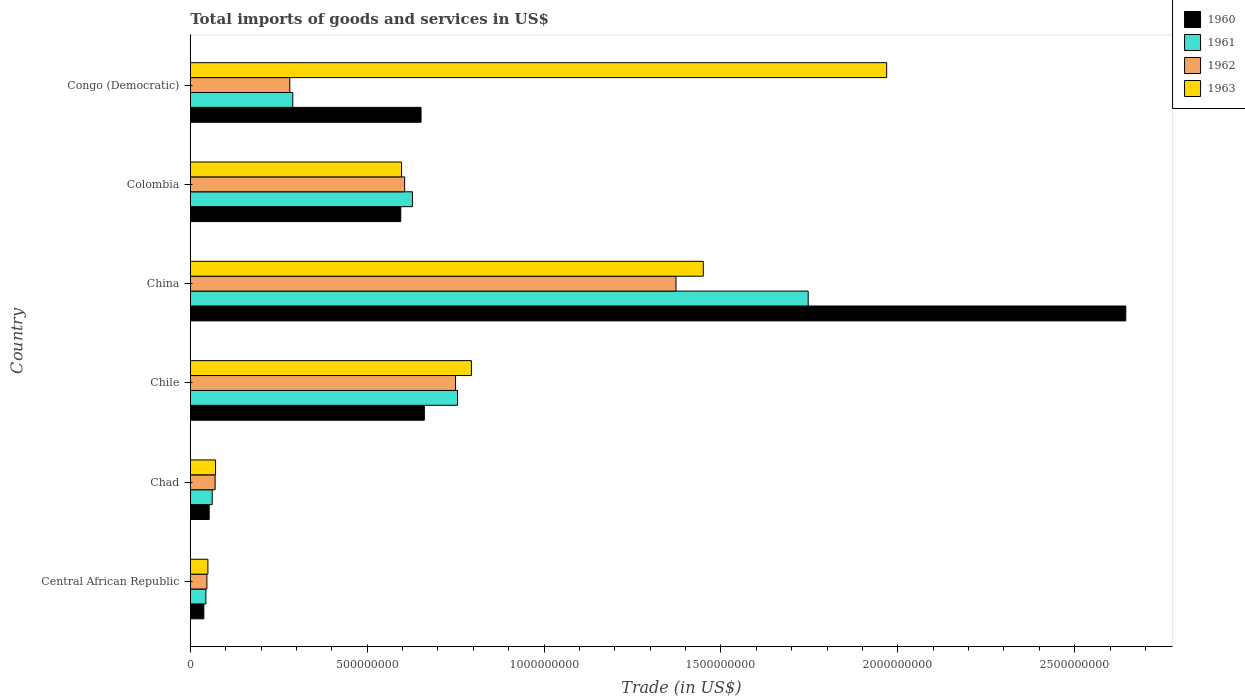Are the number of bars per tick equal to the number of legend labels?
Your answer should be very brief. Yes. In how many cases, is the number of bars for a given country not equal to the number of legend labels?
Your answer should be very brief. 0. What is the total imports of goods and services in 1960 in Central African Republic?
Offer a terse response. 3.83e+07. Across all countries, what is the maximum total imports of goods and services in 1961?
Your response must be concise. 1.75e+09. Across all countries, what is the minimum total imports of goods and services in 1961?
Give a very brief answer. 4.40e+07. In which country was the total imports of goods and services in 1963 maximum?
Keep it short and to the point. Congo (Democratic). In which country was the total imports of goods and services in 1961 minimum?
Your answer should be compact. Central African Republic. What is the total total imports of goods and services in 1960 in the graph?
Provide a succinct answer. 4.64e+09. What is the difference between the total imports of goods and services in 1963 in Chile and that in China?
Ensure brevity in your answer.  -6.55e+08. What is the difference between the total imports of goods and services in 1963 in Colombia and the total imports of goods and services in 1960 in China?
Make the answer very short. -2.05e+09. What is the average total imports of goods and services in 1960 per country?
Offer a very short reply. 7.74e+08. What is the difference between the total imports of goods and services in 1962 and total imports of goods and services in 1960 in Central African Republic?
Give a very brief answer. 8.60e+06. In how many countries, is the total imports of goods and services in 1960 greater than 1200000000 US$?
Your answer should be compact. 1. What is the ratio of the total imports of goods and services in 1960 in Central African Republic to that in Chile?
Your response must be concise. 0.06. Is the total imports of goods and services in 1960 in Central African Republic less than that in Colombia?
Your response must be concise. Yes. Is the difference between the total imports of goods and services in 1962 in Central African Republic and China greater than the difference between the total imports of goods and services in 1960 in Central African Republic and China?
Keep it short and to the point. Yes. What is the difference between the highest and the second highest total imports of goods and services in 1962?
Ensure brevity in your answer.  6.23e+08. What is the difference between the highest and the lowest total imports of goods and services in 1960?
Your answer should be very brief. 2.61e+09. In how many countries, is the total imports of goods and services in 1960 greater than the average total imports of goods and services in 1960 taken over all countries?
Your answer should be compact. 1. Is the sum of the total imports of goods and services in 1963 in Chad and Colombia greater than the maximum total imports of goods and services in 1961 across all countries?
Provide a succinct answer. No. What does the 4th bar from the top in Chad represents?
Offer a terse response. 1960. How many countries are there in the graph?
Offer a terse response. 6. What is the difference between two consecutive major ticks on the X-axis?
Make the answer very short. 5.00e+08. Does the graph contain grids?
Your response must be concise. No. Where does the legend appear in the graph?
Provide a short and direct response. Top right. How many legend labels are there?
Provide a short and direct response. 4. How are the legend labels stacked?
Provide a succinct answer. Vertical. What is the title of the graph?
Your answer should be compact. Total imports of goods and services in US$. Does "1989" appear as one of the legend labels in the graph?
Provide a short and direct response. No. What is the label or title of the X-axis?
Your answer should be compact. Trade (in US$). What is the Trade (in US$) in 1960 in Central African Republic?
Your answer should be compact. 3.83e+07. What is the Trade (in US$) of 1961 in Central African Republic?
Ensure brevity in your answer.  4.40e+07. What is the Trade (in US$) of 1962 in Central African Republic?
Provide a short and direct response. 4.69e+07. What is the Trade (in US$) in 1963 in Central African Republic?
Provide a short and direct response. 4.98e+07. What is the Trade (in US$) in 1960 in Chad?
Ensure brevity in your answer.  5.34e+07. What is the Trade (in US$) in 1961 in Chad?
Make the answer very short. 6.20e+07. What is the Trade (in US$) in 1962 in Chad?
Your response must be concise. 7.02e+07. What is the Trade (in US$) in 1963 in Chad?
Provide a succinct answer. 7.14e+07. What is the Trade (in US$) of 1960 in Chile?
Make the answer very short. 6.62e+08. What is the Trade (in US$) in 1961 in Chile?
Provide a short and direct response. 7.55e+08. What is the Trade (in US$) in 1962 in Chile?
Provide a short and direct response. 7.50e+08. What is the Trade (in US$) of 1963 in Chile?
Your answer should be compact. 7.95e+08. What is the Trade (in US$) in 1960 in China?
Your response must be concise. 2.64e+09. What is the Trade (in US$) of 1961 in China?
Your answer should be compact. 1.75e+09. What is the Trade (in US$) of 1962 in China?
Your response must be concise. 1.37e+09. What is the Trade (in US$) in 1963 in China?
Offer a very short reply. 1.45e+09. What is the Trade (in US$) in 1960 in Colombia?
Your answer should be very brief. 5.95e+08. What is the Trade (in US$) in 1961 in Colombia?
Your answer should be very brief. 6.28e+08. What is the Trade (in US$) of 1962 in Colombia?
Your answer should be compact. 6.06e+08. What is the Trade (in US$) in 1963 in Colombia?
Give a very brief answer. 5.97e+08. What is the Trade (in US$) of 1960 in Congo (Democratic)?
Offer a very short reply. 6.52e+08. What is the Trade (in US$) of 1961 in Congo (Democratic)?
Make the answer very short. 2.90e+08. What is the Trade (in US$) in 1962 in Congo (Democratic)?
Provide a succinct answer. 2.81e+08. What is the Trade (in US$) in 1963 in Congo (Democratic)?
Your answer should be very brief. 1.97e+09. Across all countries, what is the maximum Trade (in US$) of 1960?
Offer a very short reply. 2.64e+09. Across all countries, what is the maximum Trade (in US$) in 1961?
Give a very brief answer. 1.75e+09. Across all countries, what is the maximum Trade (in US$) in 1962?
Provide a short and direct response. 1.37e+09. Across all countries, what is the maximum Trade (in US$) in 1963?
Give a very brief answer. 1.97e+09. Across all countries, what is the minimum Trade (in US$) in 1960?
Your answer should be compact. 3.83e+07. Across all countries, what is the minimum Trade (in US$) of 1961?
Keep it short and to the point. 4.40e+07. Across all countries, what is the minimum Trade (in US$) of 1962?
Provide a short and direct response. 4.69e+07. Across all countries, what is the minimum Trade (in US$) in 1963?
Give a very brief answer. 4.98e+07. What is the total Trade (in US$) in 1960 in the graph?
Ensure brevity in your answer.  4.64e+09. What is the total Trade (in US$) in 1961 in the graph?
Keep it short and to the point. 3.53e+09. What is the total Trade (in US$) in 1962 in the graph?
Your answer should be compact. 3.13e+09. What is the total Trade (in US$) of 1963 in the graph?
Offer a very short reply. 4.93e+09. What is the difference between the Trade (in US$) in 1960 in Central African Republic and that in Chad?
Offer a terse response. -1.51e+07. What is the difference between the Trade (in US$) of 1961 in Central African Republic and that in Chad?
Keep it short and to the point. -1.79e+07. What is the difference between the Trade (in US$) of 1962 in Central African Republic and that in Chad?
Give a very brief answer. -2.33e+07. What is the difference between the Trade (in US$) of 1963 in Central African Republic and that in Chad?
Give a very brief answer. -2.16e+07. What is the difference between the Trade (in US$) in 1960 in Central African Republic and that in Chile?
Provide a short and direct response. -6.23e+08. What is the difference between the Trade (in US$) of 1961 in Central African Republic and that in Chile?
Keep it short and to the point. -7.11e+08. What is the difference between the Trade (in US$) of 1962 in Central African Republic and that in Chile?
Your answer should be compact. -7.03e+08. What is the difference between the Trade (in US$) in 1963 in Central African Republic and that in Chile?
Ensure brevity in your answer.  -7.45e+08. What is the difference between the Trade (in US$) of 1960 in Central African Republic and that in China?
Ensure brevity in your answer.  -2.61e+09. What is the difference between the Trade (in US$) of 1961 in Central African Republic and that in China?
Keep it short and to the point. -1.70e+09. What is the difference between the Trade (in US$) of 1962 in Central African Republic and that in China?
Your answer should be very brief. -1.33e+09. What is the difference between the Trade (in US$) of 1963 in Central African Republic and that in China?
Your response must be concise. -1.40e+09. What is the difference between the Trade (in US$) of 1960 in Central African Republic and that in Colombia?
Give a very brief answer. -5.57e+08. What is the difference between the Trade (in US$) in 1961 in Central African Republic and that in Colombia?
Provide a succinct answer. -5.84e+08. What is the difference between the Trade (in US$) of 1962 in Central African Republic and that in Colombia?
Your answer should be compact. -5.59e+08. What is the difference between the Trade (in US$) of 1963 in Central African Republic and that in Colombia?
Provide a succinct answer. -5.47e+08. What is the difference between the Trade (in US$) in 1960 in Central African Republic and that in Congo (Democratic)?
Offer a very short reply. -6.14e+08. What is the difference between the Trade (in US$) of 1961 in Central African Republic and that in Congo (Democratic)?
Provide a short and direct response. -2.46e+08. What is the difference between the Trade (in US$) in 1962 in Central African Republic and that in Congo (Democratic)?
Ensure brevity in your answer.  -2.34e+08. What is the difference between the Trade (in US$) in 1963 in Central African Republic and that in Congo (Democratic)?
Make the answer very short. -1.92e+09. What is the difference between the Trade (in US$) of 1960 in Chad and that in Chile?
Provide a short and direct response. -6.08e+08. What is the difference between the Trade (in US$) in 1961 in Chad and that in Chile?
Provide a short and direct response. -6.93e+08. What is the difference between the Trade (in US$) in 1962 in Chad and that in Chile?
Your answer should be compact. -6.80e+08. What is the difference between the Trade (in US$) in 1963 in Chad and that in Chile?
Offer a very short reply. -7.23e+08. What is the difference between the Trade (in US$) of 1960 in Chad and that in China?
Provide a short and direct response. -2.59e+09. What is the difference between the Trade (in US$) of 1961 in Chad and that in China?
Offer a very short reply. -1.68e+09. What is the difference between the Trade (in US$) of 1962 in Chad and that in China?
Ensure brevity in your answer.  -1.30e+09. What is the difference between the Trade (in US$) in 1963 in Chad and that in China?
Your response must be concise. -1.38e+09. What is the difference between the Trade (in US$) of 1960 in Chad and that in Colombia?
Make the answer very short. -5.41e+08. What is the difference between the Trade (in US$) in 1961 in Chad and that in Colombia?
Provide a succinct answer. -5.66e+08. What is the difference between the Trade (in US$) in 1962 in Chad and that in Colombia?
Provide a succinct answer. -5.36e+08. What is the difference between the Trade (in US$) of 1963 in Chad and that in Colombia?
Ensure brevity in your answer.  -5.26e+08. What is the difference between the Trade (in US$) of 1960 in Chad and that in Congo (Democratic)?
Ensure brevity in your answer.  -5.99e+08. What is the difference between the Trade (in US$) in 1961 in Chad and that in Congo (Democratic)?
Offer a very short reply. -2.28e+08. What is the difference between the Trade (in US$) in 1962 in Chad and that in Congo (Democratic)?
Make the answer very short. -2.11e+08. What is the difference between the Trade (in US$) in 1963 in Chad and that in Congo (Democratic)?
Your response must be concise. -1.90e+09. What is the difference between the Trade (in US$) in 1960 in Chile and that in China?
Your answer should be compact. -1.98e+09. What is the difference between the Trade (in US$) of 1961 in Chile and that in China?
Your answer should be compact. -9.91e+08. What is the difference between the Trade (in US$) of 1962 in Chile and that in China?
Offer a terse response. -6.23e+08. What is the difference between the Trade (in US$) of 1963 in Chile and that in China?
Offer a terse response. -6.55e+08. What is the difference between the Trade (in US$) of 1960 in Chile and that in Colombia?
Keep it short and to the point. 6.68e+07. What is the difference between the Trade (in US$) of 1961 in Chile and that in Colombia?
Make the answer very short. 1.28e+08. What is the difference between the Trade (in US$) of 1962 in Chile and that in Colombia?
Your answer should be compact. 1.44e+08. What is the difference between the Trade (in US$) in 1963 in Chile and that in Colombia?
Offer a very short reply. 1.97e+08. What is the difference between the Trade (in US$) of 1960 in Chile and that in Congo (Democratic)?
Provide a succinct answer. 9.37e+06. What is the difference between the Trade (in US$) of 1961 in Chile and that in Congo (Democratic)?
Make the answer very short. 4.66e+08. What is the difference between the Trade (in US$) in 1962 in Chile and that in Congo (Democratic)?
Make the answer very short. 4.68e+08. What is the difference between the Trade (in US$) of 1963 in Chile and that in Congo (Democratic)?
Keep it short and to the point. -1.17e+09. What is the difference between the Trade (in US$) in 1960 in China and that in Colombia?
Offer a very short reply. 2.05e+09. What is the difference between the Trade (in US$) of 1961 in China and that in Colombia?
Provide a short and direct response. 1.12e+09. What is the difference between the Trade (in US$) in 1962 in China and that in Colombia?
Your answer should be compact. 7.67e+08. What is the difference between the Trade (in US$) in 1963 in China and that in Colombia?
Ensure brevity in your answer.  8.53e+08. What is the difference between the Trade (in US$) in 1960 in China and that in Congo (Democratic)?
Make the answer very short. 1.99e+09. What is the difference between the Trade (in US$) of 1961 in China and that in Congo (Democratic)?
Your response must be concise. 1.46e+09. What is the difference between the Trade (in US$) in 1962 in China and that in Congo (Democratic)?
Your answer should be very brief. 1.09e+09. What is the difference between the Trade (in US$) of 1963 in China and that in Congo (Democratic)?
Provide a succinct answer. -5.18e+08. What is the difference between the Trade (in US$) of 1960 in Colombia and that in Congo (Democratic)?
Ensure brevity in your answer.  -5.74e+07. What is the difference between the Trade (in US$) of 1961 in Colombia and that in Congo (Democratic)?
Your answer should be very brief. 3.38e+08. What is the difference between the Trade (in US$) of 1962 in Colombia and that in Congo (Democratic)?
Your answer should be very brief. 3.25e+08. What is the difference between the Trade (in US$) of 1963 in Colombia and that in Congo (Democratic)?
Keep it short and to the point. -1.37e+09. What is the difference between the Trade (in US$) of 1960 in Central African Republic and the Trade (in US$) of 1961 in Chad?
Provide a short and direct response. -2.36e+07. What is the difference between the Trade (in US$) of 1960 in Central African Republic and the Trade (in US$) of 1962 in Chad?
Your response must be concise. -3.19e+07. What is the difference between the Trade (in US$) of 1960 in Central African Republic and the Trade (in US$) of 1963 in Chad?
Give a very brief answer. -3.31e+07. What is the difference between the Trade (in US$) of 1961 in Central African Republic and the Trade (in US$) of 1962 in Chad?
Offer a terse response. -2.62e+07. What is the difference between the Trade (in US$) in 1961 in Central African Republic and the Trade (in US$) in 1963 in Chad?
Make the answer very short. -2.74e+07. What is the difference between the Trade (in US$) in 1962 in Central African Republic and the Trade (in US$) in 1963 in Chad?
Provide a short and direct response. -2.45e+07. What is the difference between the Trade (in US$) in 1960 in Central African Republic and the Trade (in US$) in 1961 in Chile?
Your answer should be very brief. -7.17e+08. What is the difference between the Trade (in US$) of 1960 in Central African Republic and the Trade (in US$) of 1962 in Chile?
Your response must be concise. -7.11e+08. What is the difference between the Trade (in US$) in 1960 in Central African Republic and the Trade (in US$) in 1963 in Chile?
Your answer should be compact. -7.56e+08. What is the difference between the Trade (in US$) of 1961 in Central African Republic and the Trade (in US$) of 1962 in Chile?
Offer a very short reply. -7.06e+08. What is the difference between the Trade (in US$) in 1961 in Central African Republic and the Trade (in US$) in 1963 in Chile?
Offer a very short reply. -7.51e+08. What is the difference between the Trade (in US$) in 1962 in Central African Republic and the Trade (in US$) in 1963 in Chile?
Offer a very short reply. -7.48e+08. What is the difference between the Trade (in US$) in 1960 in Central African Republic and the Trade (in US$) in 1961 in China?
Your response must be concise. -1.71e+09. What is the difference between the Trade (in US$) in 1960 in Central African Republic and the Trade (in US$) in 1962 in China?
Keep it short and to the point. -1.33e+09. What is the difference between the Trade (in US$) of 1960 in Central African Republic and the Trade (in US$) of 1963 in China?
Keep it short and to the point. -1.41e+09. What is the difference between the Trade (in US$) of 1961 in Central African Republic and the Trade (in US$) of 1962 in China?
Offer a terse response. -1.33e+09. What is the difference between the Trade (in US$) of 1961 in Central African Republic and the Trade (in US$) of 1963 in China?
Give a very brief answer. -1.41e+09. What is the difference between the Trade (in US$) in 1962 in Central African Republic and the Trade (in US$) in 1963 in China?
Ensure brevity in your answer.  -1.40e+09. What is the difference between the Trade (in US$) of 1960 in Central African Republic and the Trade (in US$) of 1961 in Colombia?
Provide a succinct answer. -5.90e+08. What is the difference between the Trade (in US$) in 1960 in Central African Republic and the Trade (in US$) in 1962 in Colombia?
Keep it short and to the point. -5.68e+08. What is the difference between the Trade (in US$) in 1960 in Central African Republic and the Trade (in US$) in 1963 in Colombia?
Give a very brief answer. -5.59e+08. What is the difference between the Trade (in US$) of 1961 in Central African Republic and the Trade (in US$) of 1962 in Colombia?
Your answer should be compact. -5.62e+08. What is the difference between the Trade (in US$) of 1961 in Central African Republic and the Trade (in US$) of 1963 in Colombia?
Your answer should be compact. -5.53e+08. What is the difference between the Trade (in US$) of 1962 in Central African Republic and the Trade (in US$) of 1963 in Colombia?
Give a very brief answer. -5.50e+08. What is the difference between the Trade (in US$) in 1960 in Central African Republic and the Trade (in US$) in 1961 in Congo (Democratic)?
Provide a short and direct response. -2.51e+08. What is the difference between the Trade (in US$) of 1960 in Central African Republic and the Trade (in US$) of 1962 in Congo (Democratic)?
Keep it short and to the point. -2.43e+08. What is the difference between the Trade (in US$) in 1960 in Central African Republic and the Trade (in US$) in 1963 in Congo (Democratic)?
Your answer should be compact. -1.93e+09. What is the difference between the Trade (in US$) in 1961 in Central African Republic and the Trade (in US$) in 1962 in Congo (Democratic)?
Your answer should be compact. -2.37e+08. What is the difference between the Trade (in US$) of 1961 in Central African Republic and the Trade (in US$) of 1963 in Congo (Democratic)?
Give a very brief answer. -1.92e+09. What is the difference between the Trade (in US$) in 1962 in Central African Republic and the Trade (in US$) in 1963 in Congo (Democratic)?
Your answer should be compact. -1.92e+09. What is the difference between the Trade (in US$) of 1960 in Chad and the Trade (in US$) of 1961 in Chile?
Make the answer very short. -7.02e+08. What is the difference between the Trade (in US$) of 1960 in Chad and the Trade (in US$) of 1962 in Chile?
Your answer should be very brief. -6.96e+08. What is the difference between the Trade (in US$) in 1960 in Chad and the Trade (in US$) in 1963 in Chile?
Offer a terse response. -7.41e+08. What is the difference between the Trade (in US$) in 1961 in Chad and the Trade (in US$) in 1962 in Chile?
Provide a succinct answer. -6.88e+08. What is the difference between the Trade (in US$) of 1961 in Chad and the Trade (in US$) of 1963 in Chile?
Your answer should be compact. -7.33e+08. What is the difference between the Trade (in US$) in 1962 in Chad and the Trade (in US$) in 1963 in Chile?
Ensure brevity in your answer.  -7.25e+08. What is the difference between the Trade (in US$) of 1960 in Chad and the Trade (in US$) of 1961 in China?
Your answer should be compact. -1.69e+09. What is the difference between the Trade (in US$) in 1960 in Chad and the Trade (in US$) in 1962 in China?
Provide a short and direct response. -1.32e+09. What is the difference between the Trade (in US$) of 1960 in Chad and the Trade (in US$) of 1963 in China?
Your answer should be very brief. -1.40e+09. What is the difference between the Trade (in US$) in 1961 in Chad and the Trade (in US$) in 1962 in China?
Keep it short and to the point. -1.31e+09. What is the difference between the Trade (in US$) in 1961 in Chad and the Trade (in US$) in 1963 in China?
Your response must be concise. -1.39e+09. What is the difference between the Trade (in US$) of 1962 in Chad and the Trade (in US$) of 1963 in China?
Your answer should be compact. -1.38e+09. What is the difference between the Trade (in US$) of 1960 in Chad and the Trade (in US$) of 1961 in Colombia?
Your response must be concise. -5.75e+08. What is the difference between the Trade (in US$) in 1960 in Chad and the Trade (in US$) in 1962 in Colombia?
Offer a very short reply. -5.53e+08. What is the difference between the Trade (in US$) of 1960 in Chad and the Trade (in US$) of 1963 in Colombia?
Ensure brevity in your answer.  -5.44e+08. What is the difference between the Trade (in US$) in 1961 in Chad and the Trade (in US$) in 1962 in Colombia?
Offer a very short reply. -5.44e+08. What is the difference between the Trade (in US$) of 1961 in Chad and the Trade (in US$) of 1963 in Colombia?
Your answer should be compact. -5.35e+08. What is the difference between the Trade (in US$) of 1962 in Chad and the Trade (in US$) of 1963 in Colombia?
Your answer should be very brief. -5.27e+08. What is the difference between the Trade (in US$) of 1960 in Chad and the Trade (in US$) of 1961 in Congo (Democratic)?
Offer a very short reply. -2.36e+08. What is the difference between the Trade (in US$) in 1960 in Chad and the Trade (in US$) in 1962 in Congo (Democratic)?
Provide a short and direct response. -2.28e+08. What is the difference between the Trade (in US$) in 1960 in Chad and the Trade (in US$) in 1963 in Congo (Democratic)?
Your answer should be very brief. -1.92e+09. What is the difference between the Trade (in US$) in 1961 in Chad and the Trade (in US$) in 1962 in Congo (Democratic)?
Offer a terse response. -2.19e+08. What is the difference between the Trade (in US$) of 1961 in Chad and the Trade (in US$) of 1963 in Congo (Democratic)?
Make the answer very short. -1.91e+09. What is the difference between the Trade (in US$) of 1962 in Chad and the Trade (in US$) of 1963 in Congo (Democratic)?
Your answer should be very brief. -1.90e+09. What is the difference between the Trade (in US$) in 1960 in Chile and the Trade (in US$) in 1961 in China?
Provide a short and direct response. -1.09e+09. What is the difference between the Trade (in US$) in 1960 in Chile and the Trade (in US$) in 1962 in China?
Your answer should be compact. -7.11e+08. What is the difference between the Trade (in US$) of 1960 in Chile and the Trade (in US$) of 1963 in China?
Keep it short and to the point. -7.88e+08. What is the difference between the Trade (in US$) in 1961 in Chile and the Trade (in US$) in 1962 in China?
Provide a succinct answer. -6.18e+08. What is the difference between the Trade (in US$) of 1961 in Chile and the Trade (in US$) of 1963 in China?
Offer a terse response. -6.95e+08. What is the difference between the Trade (in US$) of 1962 in Chile and the Trade (in US$) of 1963 in China?
Give a very brief answer. -7.00e+08. What is the difference between the Trade (in US$) of 1960 in Chile and the Trade (in US$) of 1961 in Colombia?
Your answer should be compact. 3.37e+07. What is the difference between the Trade (in US$) of 1960 in Chile and the Trade (in US$) of 1962 in Colombia?
Your answer should be very brief. 5.57e+07. What is the difference between the Trade (in US$) of 1960 in Chile and the Trade (in US$) of 1963 in Colombia?
Ensure brevity in your answer.  6.44e+07. What is the difference between the Trade (in US$) in 1961 in Chile and the Trade (in US$) in 1962 in Colombia?
Make the answer very short. 1.50e+08. What is the difference between the Trade (in US$) in 1961 in Chile and the Trade (in US$) in 1963 in Colombia?
Your answer should be compact. 1.58e+08. What is the difference between the Trade (in US$) of 1962 in Chile and the Trade (in US$) of 1963 in Colombia?
Give a very brief answer. 1.52e+08. What is the difference between the Trade (in US$) of 1960 in Chile and the Trade (in US$) of 1961 in Congo (Democratic)?
Provide a short and direct response. 3.72e+08. What is the difference between the Trade (in US$) in 1960 in Chile and the Trade (in US$) in 1962 in Congo (Democratic)?
Make the answer very short. 3.80e+08. What is the difference between the Trade (in US$) of 1960 in Chile and the Trade (in US$) of 1963 in Congo (Democratic)?
Give a very brief answer. -1.31e+09. What is the difference between the Trade (in US$) of 1961 in Chile and the Trade (in US$) of 1962 in Congo (Democratic)?
Give a very brief answer. 4.74e+08. What is the difference between the Trade (in US$) in 1961 in Chile and the Trade (in US$) in 1963 in Congo (Democratic)?
Ensure brevity in your answer.  -1.21e+09. What is the difference between the Trade (in US$) in 1962 in Chile and the Trade (in US$) in 1963 in Congo (Democratic)?
Give a very brief answer. -1.22e+09. What is the difference between the Trade (in US$) in 1960 in China and the Trade (in US$) in 1961 in Colombia?
Your answer should be very brief. 2.02e+09. What is the difference between the Trade (in US$) in 1960 in China and the Trade (in US$) in 1962 in Colombia?
Your response must be concise. 2.04e+09. What is the difference between the Trade (in US$) in 1960 in China and the Trade (in US$) in 1963 in Colombia?
Keep it short and to the point. 2.05e+09. What is the difference between the Trade (in US$) in 1961 in China and the Trade (in US$) in 1962 in Colombia?
Offer a very short reply. 1.14e+09. What is the difference between the Trade (in US$) of 1961 in China and the Trade (in US$) of 1963 in Colombia?
Offer a very short reply. 1.15e+09. What is the difference between the Trade (in US$) of 1962 in China and the Trade (in US$) of 1963 in Colombia?
Provide a short and direct response. 7.76e+08. What is the difference between the Trade (in US$) of 1960 in China and the Trade (in US$) of 1961 in Congo (Democratic)?
Provide a succinct answer. 2.35e+09. What is the difference between the Trade (in US$) in 1960 in China and the Trade (in US$) in 1962 in Congo (Democratic)?
Your answer should be very brief. 2.36e+09. What is the difference between the Trade (in US$) of 1960 in China and the Trade (in US$) of 1963 in Congo (Democratic)?
Your answer should be very brief. 6.76e+08. What is the difference between the Trade (in US$) of 1961 in China and the Trade (in US$) of 1962 in Congo (Democratic)?
Offer a very short reply. 1.47e+09. What is the difference between the Trade (in US$) of 1961 in China and the Trade (in US$) of 1963 in Congo (Democratic)?
Your answer should be very brief. -2.22e+08. What is the difference between the Trade (in US$) in 1962 in China and the Trade (in US$) in 1963 in Congo (Democratic)?
Provide a succinct answer. -5.96e+08. What is the difference between the Trade (in US$) in 1960 in Colombia and the Trade (in US$) in 1961 in Congo (Democratic)?
Offer a very short reply. 3.05e+08. What is the difference between the Trade (in US$) in 1960 in Colombia and the Trade (in US$) in 1962 in Congo (Democratic)?
Make the answer very short. 3.14e+08. What is the difference between the Trade (in US$) of 1960 in Colombia and the Trade (in US$) of 1963 in Congo (Democratic)?
Provide a short and direct response. -1.37e+09. What is the difference between the Trade (in US$) of 1961 in Colombia and the Trade (in US$) of 1962 in Congo (Democratic)?
Ensure brevity in your answer.  3.47e+08. What is the difference between the Trade (in US$) of 1961 in Colombia and the Trade (in US$) of 1963 in Congo (Democratic)?
Offer a very short reply. -1.34e+09. What is the difference between the Trade (in US$) in 1962 in Colombia and the Trade (in US$) in 1963 in Congo (Democratic)?
Offer a terse response. -1.36e+09. What is the average Trade (in US$) of 1960 per country?
Provide a short and direct response. 7.74e+08. What is the average Trade (in US$) of 1961 per country?
Offer a very short reply. 5.88e+08. What is the average Trade (in US$) of 1962 per country?
Your answer should be very brief. 5.21e+08. What is the average Trade (in US$) in 1963 per country?
Your response must be concise. 8.22e+08. What is the difference between the Trade (in US$) in 1960 and Trade (in US$) in 1961 in Central African Republic?
Provide a succinct answer. -5.70e+06. What is the difference between the Trade (in US$) in 1960 and Trade (in US$) in 1962 in Central African Republic?
Provide a short and direct response. -8.60e+06. What is the difference between the Trade (in US$) in 1960 and Trade (in US$) in 1963 in Central African Republic?
Offer a very short reply. -1.15e+07. What is the difference between the Trade (in US$) of 1961 and Trade (in US$) of 1962 in Central African Republic?
Provide a succinct answer. -2.90e+06. What is the difference between the Trade (in US$) in 1961 and Trade (in US$) in 1963 in Central African Republic?
Ensure brevity in your answer.  -5.76e+06. What is the difference between the Trade (in US$) in 1962 and Trade (in US$) in 1963 in Central African Republic?
Keep it short and to the point. -2.86e+06. What is the difference between the Trade (in US$) in 1960 and Trade (in US$) in 1961 in Chad?
Provide a short and direct response. -8.55e+06. What is the difference between the Trade (in US$) of 1960 and Trade (in US$) of 1962 in Chad?
Offer a very short reply. -1.68e+07. What is the difference between the Trade (in US$) of 1960 and Trade (in US$) of 1963 in Chad?
Your answer should be very brief. -1.80e+07. What is the difference between the Trade (in US$) of 1961 and Trade (in US$) of 1962 in Chad?
Your answer should be compact. -8.23e+06. What is the difference between the Trade (in US$) of 1961 and Trade (in US$) of 1963 in Chad?
Give a very brief answer. -9.45e+06. What is the difference between the Trade (in US$) in 1962 and Trade (in US$) in 1963 in Chad?
Ensure brevity in your answer.  -1.22e+06. What is the difference between the Trade (in US$) of 1960 and Trade (in US$) of 1961 in Chile?
Offer a very short reply. -9.38e+07. What is the difference between the Trade (in US$) of 1960 and Trade (in US$) of 1962 in Chile?
Offer a terse response. -8.81e+07. What is the difference between the Trade (in US$) of 1960 and Trade (in US$) of 1963 in Chile?
Your response must be concise. -1.33e+08. What is the difference between the Trade (in US$) in 1961 and Trade (in US$) in 1962 in Chile?
Give a very brief answer. 5.71e+06. What is the difference between the Trade (in US$) in 1961 and Trade (in US$) in 1963 in Chile?
Provide a short and direct response. -3.92e+07. What is the difference between the Trade (in US$) of 1962 and Trade (in US$) of 1963 in Chile?
Your answer should be very brief. -4.50e+07. What is the difference between the Trade (in US$) in 1960 and Trade (in US$) in 1961 in China?
Your answer should be compact. 8.98e+08. What is the difference between the Trade (in US$) in 1960 and Trade (in US$) in 1962 in China?
Offer a terse response. 1.27e+09. What is the difference between the Trade (in US$) in 1960 and Trade (in US$) in 1963 in China?
Your response must be concise. 1.19e+09. What is the difference between the Trade (in US$) of 1961 and Trade (in US$) of 1962 in China?
Offer a terse response. 3.74e+08. What is the difference between the Trade (in US$) of 1961 and Trade (in US$) of 1963 in China?
Give a very brief answer. 2.97e+08. What is the difference between the Trade (in US$) in 1962 and Trade (in US$) in 1963 in China?
Keep it short and to the point. -7.72e+07. What is the difference between the Trade (in US$) in 1960 and Trade (in US$) in 1961 in Colombia?
Your response must be concise. -3.30e+07. What is the difference between the Trade (in US$) of 1960 and Trade (in US$) of 1962 in Colombia?
Keep it short and to the point. -1.10e+07. What is the difference between the Trade (in US$) in 1960 and Trade (in US$) in 1963 in Colombia?
Give a very brief answer. -2.39e+06. What is the difference between the Trade (in US$) of 1961 and Trade (in US$) of 1962 in Colombia?
Ensure brevity in your answer.  2.20e+07. What is the difference between the Trade (in US$) of 1961 and Trade (in US$) of 1963 in Colombia?
Provide a succinct answer. 3.06e+07. What is the difference between the Trade (in US$) of 1962 and Trade (in US$) of 1963 in Colombia?
Give a very brief answer. 8.64e+06. What is the difference between the Trade (in US$) in 1960 and Trade (in US$) in 1961 in Congo (Democratic)?
Offer a very short reply. 3.63e+08. What is the difference between the Trade (in US$) of 1960 and Trade (in US$) of 1962 in Congo (Democratic)?
Your response must be concise. 3.71e+08. What is the difference between the Trade (in US$) in 1960 and Trade (in US$) in 1963 in Congo (Democratic)?
Ensure brevity in your answer.  -1.32e+09. What is the difference between the Trade (in US$) in 1961 and Trade (in US$) in 1962 in Congo (Democratic)?
Offer a terse response. 8.49e+06. What is the difference between the Trade (in US$) in 1961 and Trade (in US$) in 1963 in Congo (Democratic)?
Keep it short and to the point. -1.68e+09. What is the difference between the Trade (in US$) of 1962 and Trade (in US$) of 1963 in Congo (Democratic)?
Make the answer very short. -1.69e+09. What is the ratio of the Trade (in US$) of 1960 in Central African Republic to that in Chad?
Your answer should be very brief. 0.72. What is the ratio of the Trade (in US$) of 1961 in Central African Republic to that in Chad?
Keep it short and to the point. 0.71. What is the ratio of the Trade (in US$) in 1962 in Central African Republic to that in Chad?
Your response must be concise. 0.67. What is the ratio of the Trade (in US$) in 1963 in Central African Republic to that in Chad?
Give a very brief answer. 0.7. What is the ratio of the Trade (in US$) of 1960 in Central African Republic to that in Chile?
Keep it short and to the point. 0.06. What is the ratio of the Trade (in US$) of 1961 in Central African Republic to that in Chile?
Offer a terse response. 0.06. What is the ratio of the Trade (in US$) of 1962 in Central African Republic to that in Chile?
Offer a very short reply. 0.06. What is the ratio of the Trade (in US$) in 1963 in Central African Republic to that in Chile?
Provide a short and direct response. 0.06. What is the ratio of the Trade (in US$) of 1960 in Central African Republic to that in China?
Offer a very short reply. 0.01. What is the ratio of the Trade (in US$) of 1961 in Central African Republic to that in China?
Your response must be concise. 0.03. What is the ratio of the Trade (in US$) in 1962 in Central African Republic to that in China?
Your answer should be very brief. 0.03. What is the ratio of the Trade (in US$) in 1963 in Central African Republic to that in China?
Give a very brief answer. 0.03. What is the ratio of the Trade (in US$) in 1960 in Central African Republic to that in Colombia?
Provide a succinct answer. 0.06. What is the ratio of the Trade (in US$) of 1961 in Central African Republic to that in Colombia?
Provide a short and direct response. 0.07. What is the ratio of the Trade (in US$) in 1962 in Central African Republic to that in Colombia?
Offer a very short reply. 0.08. What is the ratio of the Trade (in US$) in 1963 in Central African Republic to that in Colombia?
Keep it short and to the point. 0.08. What is the ratio of the Trade (in US$) in 1960 in Central African Republic to that in Congo (Democratic)?
Your answer should be compact. 0.06. What is the ratio of the Trade (in US$) in 1961 in Central African Republic to that in Congo (Democratic)?
Offer a terse response. 0.15. What is the ratio of the Trade (in US$) of 1962 in Central African Republic to that in Congo (Democratic)?
Your response must be concise. 0.17. What is the ratio of the Trade (in US$) in 1963 in Central African Republic to that in Congo (Democratic)?
Make the answer very short. 0.03. What is the ratio of the Trade (in US$) in 1960 in Chad to that in Chile?
Offer a terse response. 0.08. What is the ratio of the Trade (in US$) of 1961 in Chad to that in Chile?
Provide a short and direct response. 0.08. What is the ratio of the Trade (in US$) of 1962 in Chad to that in Chile?
Offer a very short reply. 0.09. What is the ratio of the Trade (in US$) of 1963 in Chad to that in Chile?
Make the answer very short. 0.09. What is the ratio of the Trade (in US$) in 1960 in Chad to that in China?
Offer a terse response. 0.02. What is the ratio of the Trade (in US$) in 1961 in Chad to that in China?
Provide a succinct answer. 0.04. What is the ratio of the Trade (in US$) in 1962 in Chad to that in China?
Provide a short and direct response. 0.05. What is the ratio of the Trade (in US$) of 1963 in Chad to that in China?
Keep it short and to the point. 0.05. What is the ratio of the Trade (in US$) in 1960 in Chad to that in Colombia?
Your answer should be compact. 0.09. What is the ratio of the Trade (in US$) of 1961 in Chad to that in Colombia?
Your response must be concise. 0.1. What is the ratio of the Trade (in US$) of 1962 in Chad to that in Colombia?
Your response must be concise. 0.12. What is the ratio of the Trade (in US$) of 1963 in Chad to that in Colombia?
Your answer should be compact. 0.12. What is the ratio of the Trade (in US$) in 1960 in Chad to that in Congo (Democratic)?
Keep it short and to the point. 0.08. What is the ratio of the Trade (in US$) in 1961 in Chad to that in Congo (Democratic)?
Give a very brief answer. 0.21. What is the ratio of the Trade (in US$) in 1962 in Chad to that in Congo (Democratic)?
Your answer should be compact. 0.25. What is the ratio of the Trade (in US$) in 1963 in Chad to that in Congo (Democratic)?
Give a very brief answer. 0.04. What is the ratio of the Trade (in US$) of 1960 in Chile to that in China?
Ensure brevity in your answer.  0.25. What is the ratio of the Trade (in US$) in 1961 in Chile to that in China?
Offer a terse response. 0.43. What is the ratio of the Trade (in US$) of 1962 in Chile to that in China?
Your response must be concise. 0.55. What is the ratio of the Trade (in US$) in 1963 in Chile to that in China?
Give a very brief answer. 0.55. What is the ratio of the Trade (in US$) of 1960 in Chile to that in Colombia?
Give a very brief answer. 1.11. What is the ratio of the Trade (in US$) in 1961 in Chile to that in Colombia?
Give a very brief answer. 1.2. What is the ratio of the Trade (in US$) of 1962 in Chile to that in Colombia?
Offer a terse response. 1.24. What is the ratio of the Trade (in US$) of 1963 in Chile to that in Colombia?
Provide a succinct answer. 1.33. What is the ratio of the Trade (in US$) in 1960 in Chile to that in Congo (Democratic)?
Your answer should be very brief. 1.01. What is the ratio of the Trade (in US$) in 1961 in Chile to that in Congo (Democratic)?
Ensure brevity in your answer.  2.61. What is the ratio of the Trade (in US$) in 1962 in Chile to that in Congo (Democratic)?
Keep it short and to the point. 2.67. What is the ratio of the Trade (in US$) of 1963 in Chile to that in Congo (Democratic)?
Keep it short and to the point. 0.4. What is the ratio of the Trade (in US$) of 1960 in China to that in Colombia?
Make the answer very short. 4.45. What is the ratio of the Trade (in US$) of 1961 in China to that in Colombia?
Ensure brevity in your answer.  2.78. What is the ratio of the Trade (in US$) of 1962 in China to that in Colombia?
Ensure brevity in your answer.  2.27. What is the ratio of the Trade (in US$) in 1963 in China to that in Colombia?
Provide a short and direct response. 2.43. What is the ratio of the Trade (in US$) of 1960 in China to that in Congo (Democratic)?
Make the answer very short. 4.05. What is the ratio of the Trade (in US$) in 1961 in China to that in Congo (Democratic)?
Your response must be concise. 6.03. What is the ratio of the Trade (in US$) of 1962 in China to that in Congo (Democratic)?
Offer a terse response. 4.88. What is the ratio of the Trade (in US$) in 1963 in China to that in Congo (Democratic)?
Offer a very short reply. 0.74. What is the ratio of the Trade (in US$) of 1960 in Colombia to that in Congo (Democratic)?
Your answer should be compact. 0.91. What is the ratio of the Trade (in US$) of 1961 in Colombia to that in Congo (Democratic)?
Give a very brief answer. 2.17. What is the ratio of the Trade (in US$) in 1962 in Colombia to that in Congo (Democratic)?
Ensure brevity in your answer.  2.15. What is the ratio of the Trade (in US$) in 1963 in Colombia to that in Congo (Democratic)?
Provide a succinct answer. 0.3. What is the difference between the highest and the second highest Trade (in US$) in 1960?
Provide a succinct answer. 1.98e+09. What is the difference between the highest and the second highest Trade (in US$) of 1961?
Your response must be concise. 9.91e+08. What is the difference between the highest and the second highest Trade (in US$) of 1962?
Provide a short and direct response. 6.23e+08. What is the difference between the highest and the second highest Trade (in US$) of 1963?
Ensure brevity in your answer.  5.18e+08. What is the difference between the highest and the lowest Trade (in US$) in 1960?
Keep it short and to the point. 2.61e+09. What is the difference between the highest and the lowest Trade (in US$) in 1961?
Make the answer very short. 1.70e+09. What is the difference between the highest and the lowest Trade (in US$) of 1962?
Ensure brevity in your answer.  1.33e+09. What is the difference between the highest and the lowest Trade (in US$) in 1963?
Make the answer very short. 1.92e+09. 